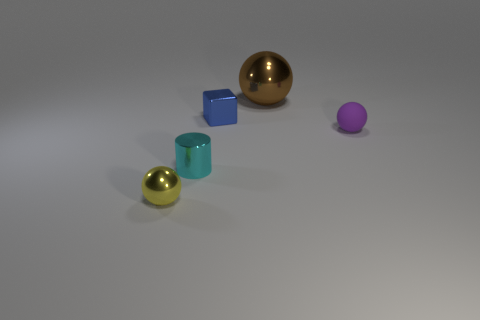Is the brown metallic thing the same shape as the small purple rubber object?
Make the answer very short. Yes. The tiny sphere that is the same material as the block is what color?
Provide a short and direct response. Yellow. What number of objects are things that are in front of the cyan thing or cyan metallic cylinders?
Offer a terse response. 2. What size is the sphere that is in front of the tiny matte object?
Offer a very short reply. Small. Does the brown object have the same size as the yellow thing that is in front of the cyan object?
Your response must be concise. No. The tiny ball that is behind the tiny sphere that is left of the big brown shiny ball is what color?
Your answer should be very brief. Purple. How many other things are the same color as the metal cylinder?
Your answer should be very brief. 0. How big is the yellow shiny thing?
Offer a terse response. Small. Is the number of blue metallic objects behind the small blue metallic object greater than the number of big metal objects on the left side of the brown metallic sphere?
Ensure brevity in your answer.  No. There is a small ball that is to the left of the purple object; what number of small spheres are behind it?
Your answer should be very brief. 1. 